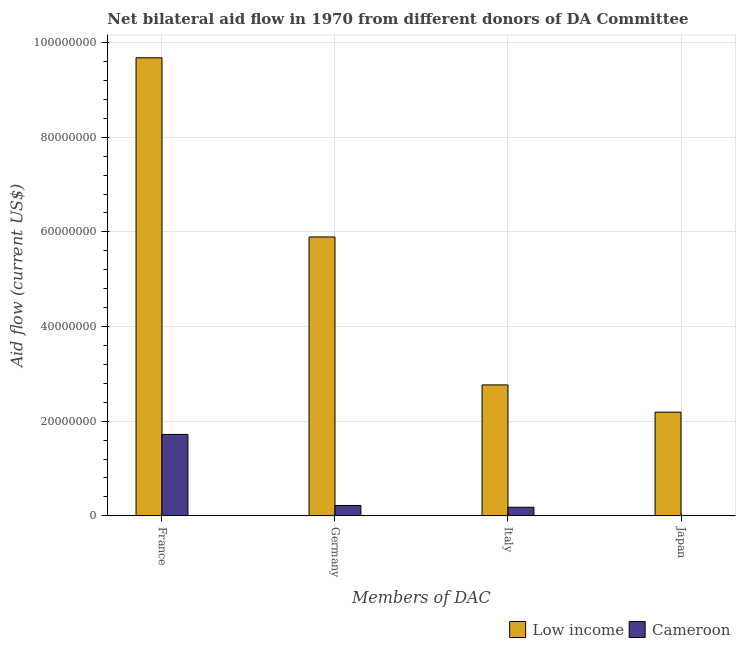How many groups of bars are there?
Your answer should be very brief. 4. Are the number of bars per tick equal to the number of legend labels?
Ensure brevity in your answer.  Yes. Are the number of bars on each tick of the X-axis equal?
Give a very brief answer. Yes. How many bars are there on the 2nd tick from the right?
Keep it short and to the point. 2. What is the amount of aid given by italy in Low income?
Your answer should be compact. 2.77e+07. Across all countries, what is the maximum amount of aid given by germany?
Offer a very short reply. 5.89e+07. Across all countries, what is the minimum amount of aid given by france?
Your answer should be compact. 1.72e+07. In which country was the amount of aid given by germany minimum?
Your answer should be compact. Cameroon. What is the total amount of aid given by germany in the graph?
Your answer should be very brief. 6.11e+07. What is the difference between the amount of aid given by japan in Cameroon and that in Low income?
Give a very brief answer. -2.19e+07. What is the difference between the amount of aid given by italy in Cameroon and the amount of aid given by germany in Low income?
Keep it short and to the point. -5.71e+07. What is the average amount of aid given by japan per country?
Your response must be concise. 1.10e+07. What is the difference between the amount of aid given by france and amount of aid given by germany in Cameroon?
Offer a very short reply. 1.50e+07. In how many countries, is the amount of aid given by japan greater than 88000000 US$?
Make the answer very short. 0. What is the ratio of the amount of aid given by germany in Cameroon to that in Low income?
Offer a terse response. 0.04. Is the amount of aid given by germany in Low income less than that in Cameroon?
Make the answer very short. No. What is the difference between the highest and the second highest amount of aid given by japan?
Your response must be concise. 2.19e+07. What is the difference between the highest and the lowest amount of aid given by france?
Your answer should be very brief. 7.96e+07. Is it the case that in every country, the sum of the amount of aid given by italy and amount of aid given by germany is greater than the sum of amount of aid given by japan and amount of aid given by france?
Provide a short and direct response. No. What does the 2nd bar from the left in Japan represents?
Ensure brevity in your answer.  Cameroon. What does the 1st bar from the right in Italy represents?
Your response must be concise. Cameroon. Is it the case that in every country, the sum of the amount of aid given by france and amount of aid given by germany is greater than the amount of aid given by italy?
Your answer should be very brief. Yes. How many countries are there in the graph?
Offer a terse response. 2. How are the legend labels stacked?
Keep it short and to the point. Horizontal. What is the title of the graph?
Ensure brevity in your answer.  Net bilateral aid flow in 1970 from different donors of DA Committee. Does "Netherlands" appear as one of the legend labels in the graph?
Your answer should be very brief. No. What is the label or title of the X-axis?
Ensure brevity in your answer.  Members of DAC. What is the Aid flow (current US$) of Low income in France?
Your response must be concise. 9.68e+07. What is the Aid flow (current US$) of Cameroon in France?
Ensure brevity in your answer.  1.72e+07. What is the Aid flow (current US$) in Low income in Germany?
Give a very brief answer. 5.89e+07. What is the Aid flow (current US$) in Cameroon in Germany?
Offer a very short reply. 2.18e+06. What is the Aid flow (current US$) in Low income in Italy?
Provide a short and direct response. 2.77e+07. What is the Aid flow (current US$) in Cameroon in Italy?
Provide a short and direct response. 1.81e+06. What is the Aid flow (current US$) of Low income in Japan?
Offer a terse response. 2.19e+07. Across all Members of DAC, what is the maximum Aid flow (current US$) of Low income?
Your answer should be very brief. 9.68e+07. Across all Members of DAC, what is the maximum Aid flow (current US$) in Cameroon?
Your response must be concise. 1.72e+07. Across all Members of DAC, what is the minimum Aid flow (current US$) of Low income?
Give a very brief answer. 2.19e+07. What is the total Aid flow (current US$) in Low income in the graph?
Give a very brief answer. 2.05e+08. What is the total Aid flow (current US$) of Cameroon in the graph?
Give a very brief answer. 2.12e+07. What is the difference between the Aid flow (current US$) in Low income in France and that in Germany?
Offer a terse response. 3.79e+07. What is the difference between the Aid flow (current US$) of Cameroon in France and that in Germany?
Your answer should be compact. 1.50e+07. What is the difference between the Aid flow (current US$) of Low income in France and that in Italy?
Your answer should be very brief. 6.91e+07. What is the difference between the Aid flow (current US$) in Cameroon in France and that in Italy?
Give a very brief answer. 1.54e+07. What is the difference between the Aid flow (current US$) in Low income in France and that in Japan?
Your answer should be very brief. 7.49e+07. What is the difference between the Aid flow (current US$) in Cameroon in France and that in Japan?
Give a very brief answer. 1.72e+07. What is the difference between the Aid flow (current US$) of Low income in Germany and that in Italy?
Make the answer very short. 3.13e+07. What is the difference between the Aid flow (current US$) in Cameroon in Germany and that in Italy?
Offer a terse response. 3.70e+05. What is the difference between the Aid flow (current US$) in Low income in Germany and that in Japan?
Ensure brevity in your answer.  3.70e+07. What is the difference between the Aid flow (current US$) of Cameroon in Germany and that in Japan?
Offer a very short reply. 2.17e+06. What is the difference between the Aid flow (current US$) of Low income in Italy and that in Japan?
Your response must be concise. 5.76e+06. What is the difference between the Aid flow (current US$) of Cameroon in Italy and that in Japan?
Provide a succinct answer. 1.80e+06. What is the difference between the Aid flow (current US$) in Low income in France and the Aid flow (current US$) in Cameroon in Germany?
Provide a short and direct response. 9.46e+07. What is the difference between the Aid flow (current US$) in Low income in France and the Aid flow (current US$) in Cameroon in Italy?
Offer a terse response. 9.50e+07. What is the difference between the Aid flow (current US$) of Low income in France and the Aid flow (current US$) of Cameroon in Japan?
Your answer should be very brief. 9.68e+07. What is the difference between the Aid flow (current US$) of Low income in Germany and the Aid flow (current US$) of Cameroon in Italy?
Give a very brief answer. 5.71e+07. What is the difference between the Aid flow (current US$) in Low income in Germany and the Aid flow (current US$) in Cameroon in Japan?
Your answer should be very brief. 5.89e+07. What is the difference between the Aid flow (current US$) in Low income in Italy and the Aid flow (current US$) in Cameroon in Japan?
Your answer should be very brief. 2.76e+07. What is the average Aid flow (current US$) in Low income per Members of DAC?
Your answer should be very brief. 5.13e+07. What is the average Aid flow (current US$) of Cameroon per Members of DAC?
Your response must be concise. 5.30e+06. What is the difference between the Aid flow (current US$) in Low income and Aid flow (current US$) in Cameroon in France?
Offer a terse response. 7.96e+07. What is the difference between the Aid flow (current US$) in Low income and Aid flow (current US$) in Cameroon in Germany?
Keep it short and to the point. 5.68e+07. What is the difference between the Aid flow (current US$) of Low income and Aid flow (current US$) of Cameroon in Italy?
Provide a short and direct response. 2.58e+07. What is the difference between the Aid flow (current US$) in Low income and Aid flow (current US$) in Cameroon in Japan?
Provide a short and direct response. 2.19e+07. What is the ratio of the Aid flow (current US$) in Low income in France to that in Germany?
Your response must be concise. 1.64. What is the ratio of the Aid flow (current US$) of Cameroon in France to that in Germany?
Your answer should be compact. 7.89. What is the ratio of the Aid flow (current US$) in Low income in France to that in Italy?
Make the answer very short. 3.5. What is the ratio of the Aid flow (current US$) in Cameroon in France to that in Italy?
Offer a terse response. 9.5. What is the ratio of the Aid flow (current US$) in Low income in France to that in Japan?
Ensure brevity in your answer.  4.42. What is the ratio of the Aid flow (current US$) in Cameroon in France to that in Japan?
Provide a succinct answer. 1720. What is the ratio of the Aid flow (current US$) in Low income in Germany to that in Italy?
Your answer should be compact. 2.13. What is the ratio of the Aid flow (current US$) of Cameroon in Germany to that in Italy?
Give a very brief answer. 1.2. What is the ratio of the Aid flow (current US$) of Low income in Germany to that in Japan?
Give a very brief answer. 2.69. What is the ratio of the Aid flow (current US$) in Cameroon in Germany to that in Japan?
Your answer should be compact. 218. What is the ratio of the Aid flow (current US$) of Low income in Italy to that in Japan?
Your answer should be very brief. 1.26. What is the ratio of the Aid flow (current US$) in Cameroon in Italy to that in Japan?
Offer a very short reply. 181. What is the difference between the highest and the second highest Aid flow (current US$) of Low income?
Make the answer very short. 3.79e+07. What is the difference between the highest and the second highest Aid flow (current US$) in Cameroon?
Provide a short and direct response. 1.50e+07. What is the difference between the highest and the lowest Aid flow (current US$) of Low income?
Offer a very short reply. 7.49e+07. What is the difference between the highest and the lowest Aid flow (current US$) of Cameroon?
Your answer should be very brief. 1.72e+07. 